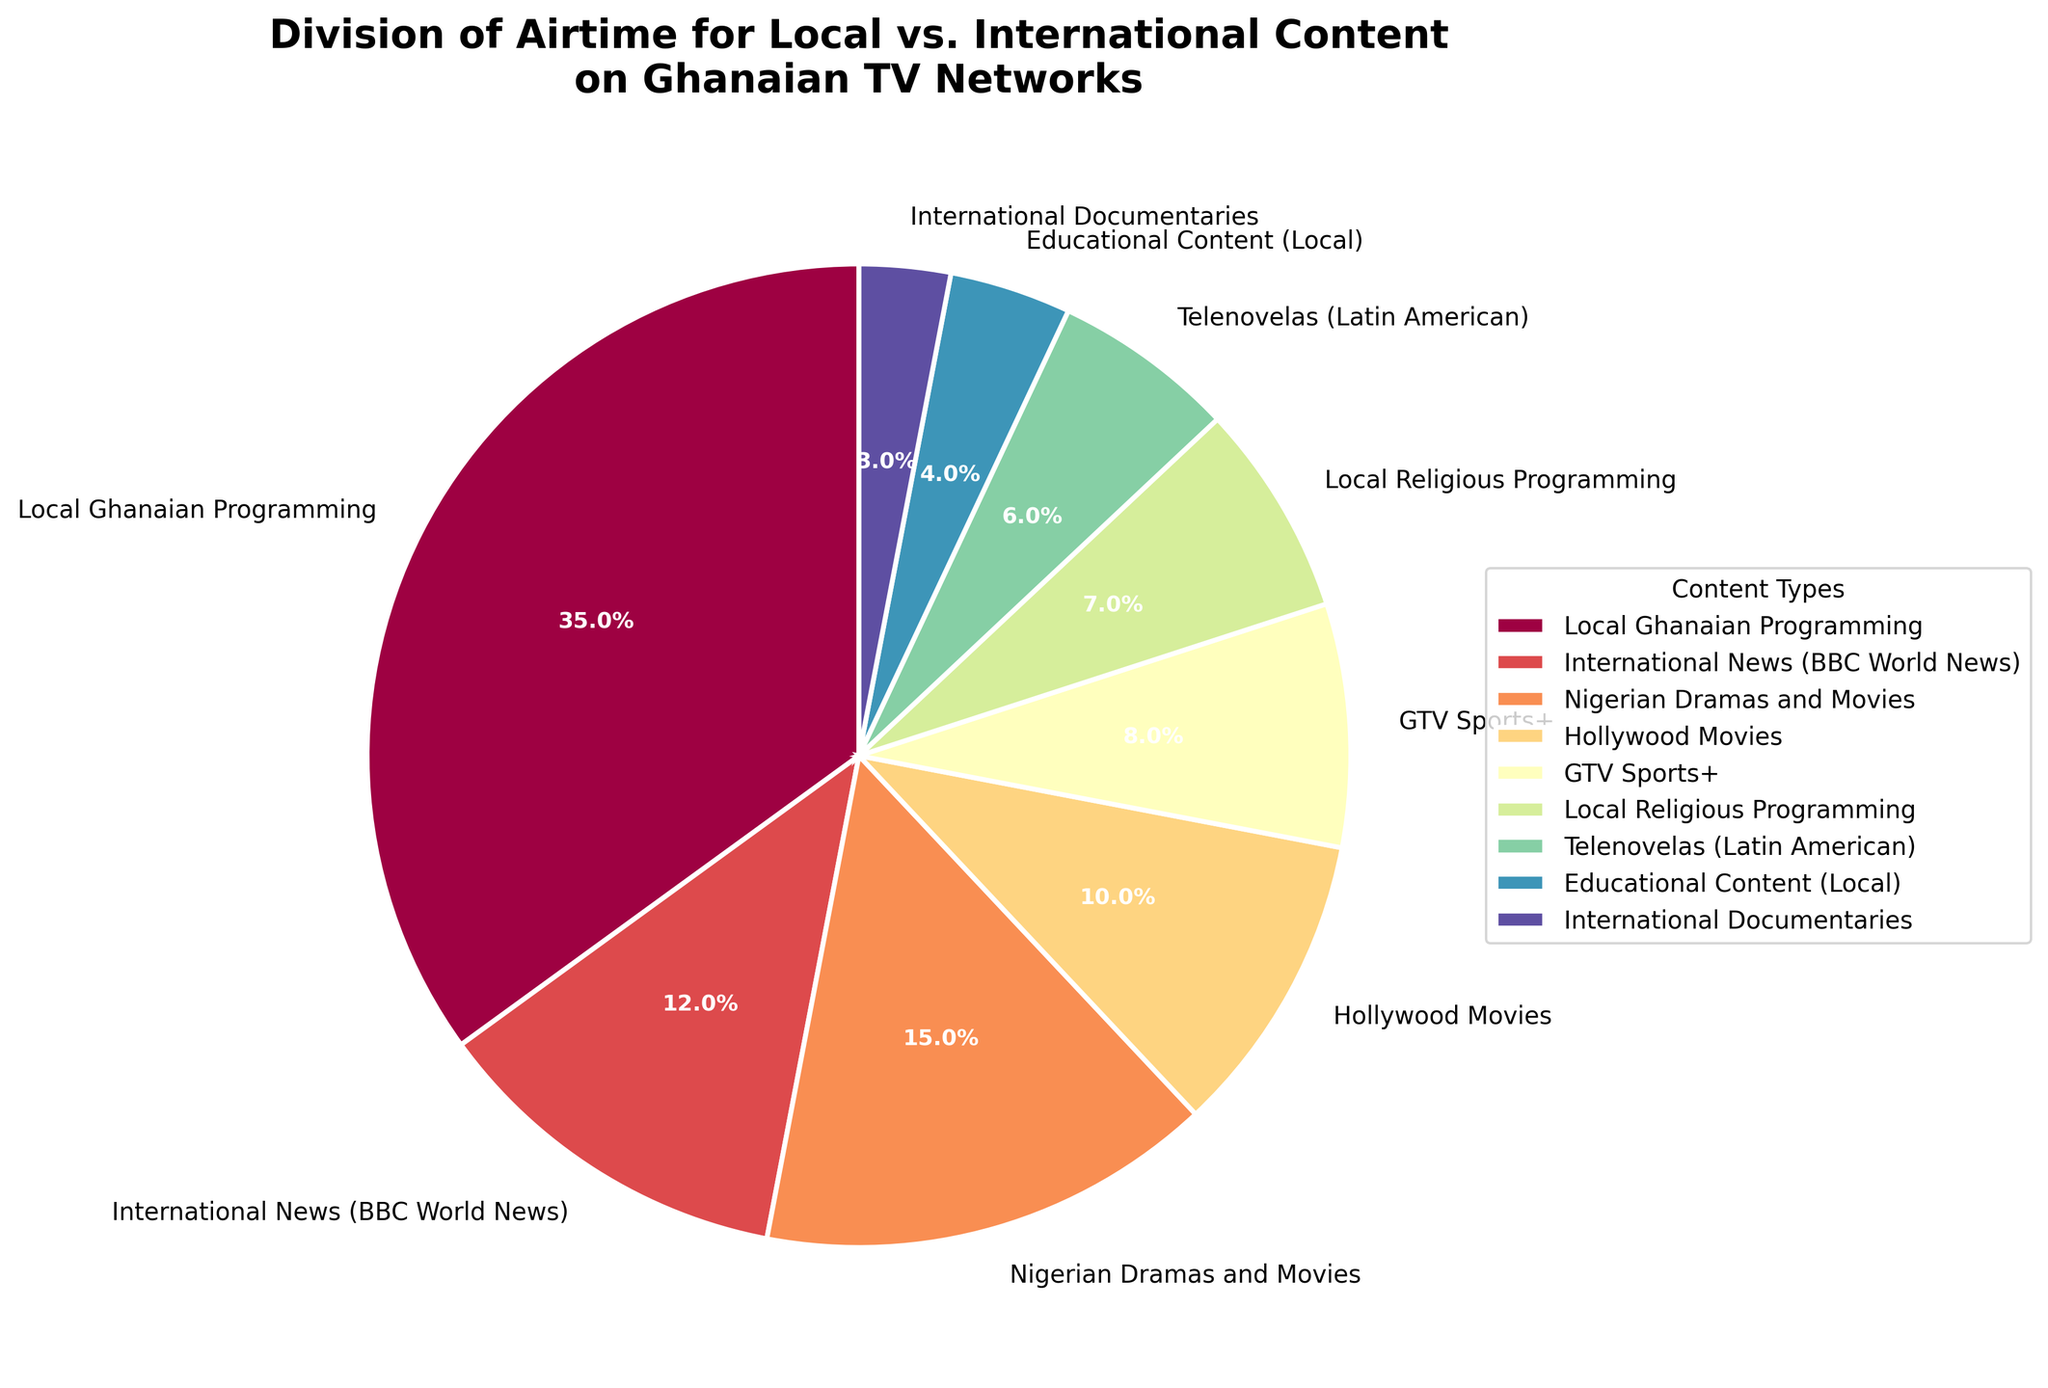What is the airtime percentage for local Ghanaian programming? According to the figure, the wedge labeled "Local Ghanaian Programming" indicates the percentage.
Answer: 35% Which content type has the smallest airtime percentage? By observing the sizes of the wedges, we can see that "International Documentaries" has the smallest wedge.
Answer: International Documentaries What is the total airtime percentage dedicated to international content? Sum the percentages of international content: International News (12%) + Hollywood Movies (10%) + Telenovelas (6%) + International Documentaries (3%).
Answer: 31% How does the airtime percentage for local religious programming compare to that of GTV Sports+? Local religious programming has a wedge of 7% while GTV Sports+ has 8%. Therefore, GTV Sports+ receives a higher percentage.
Answer: GTV Sports+ has more airtime than Local Religious Programming What is the sum of airtime percentages for local Ghanaian programming, GTV Sports+, and local religious programming? Sum the respective percentages: 35% (Local Ghanaian Programming) + 8% (GTV Sports+) + 7% (Local Religious Programming).
Answer: 50% Which content type has a 6% airtime share and how is it visually represented? The wedge labeled "Telenovelas (Latin American)" has a 6% share, which is colored according to the hue near the lower end of the spectrum used.
Answer: Telenovelas (Latin American) How does the airtime for Nigerian dramas and movies compare to that for Hollywood movies? Nigerian Dramas and Movies have a wedge representing 15% and Hollywood Movies represent 10%. Thus, Nigerian Dramas and Movies have more airtime.
Answer: Nigerian Dramas and Movies have more airtime than Hollywood Movies What is the airtime percentage difference between local educational content and international documentaries? Subtract the percentage for International Documentaries (3%) from Local Educational Content (4%).
Answer: 1% Combine the airtime percentages for all religious and educational content shown in the chart. Add percentages: Local Religious Programming (7%) + Educational Content (Local, 4%).
Answer: 11% What color is used for the wedge representing Hollywood Movies, and what is its airtime percentage? The wedge for Hollywood Movies is colored in a hue close to the middle of the gradient and it represents 10% of the airtime.
Answer: Hollywood Movies; 10% 